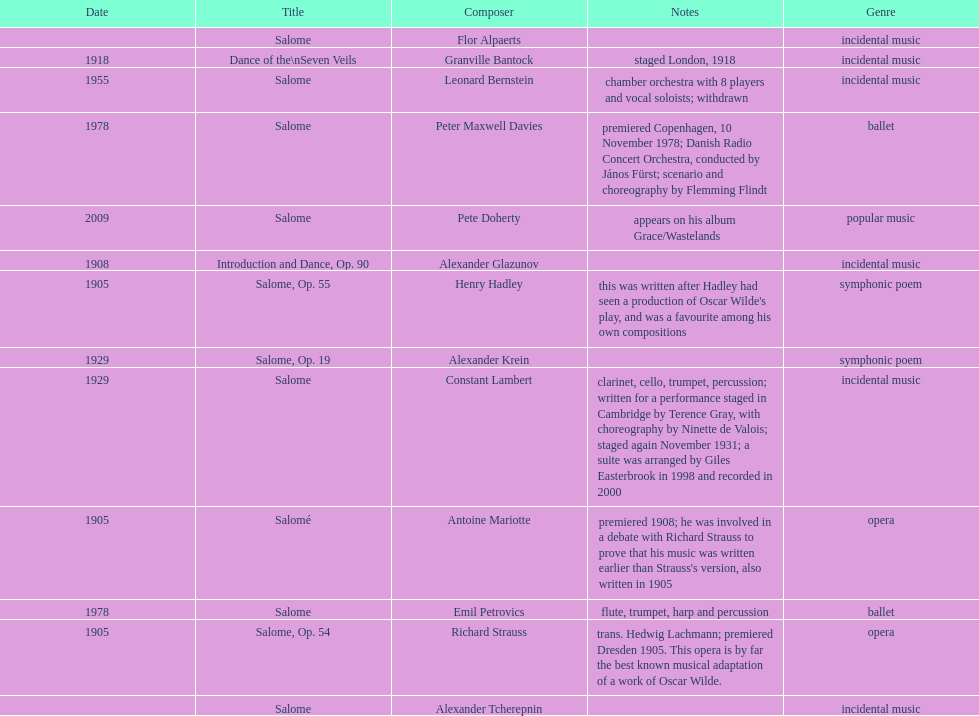What is the number of works titled "salome?" 11. 